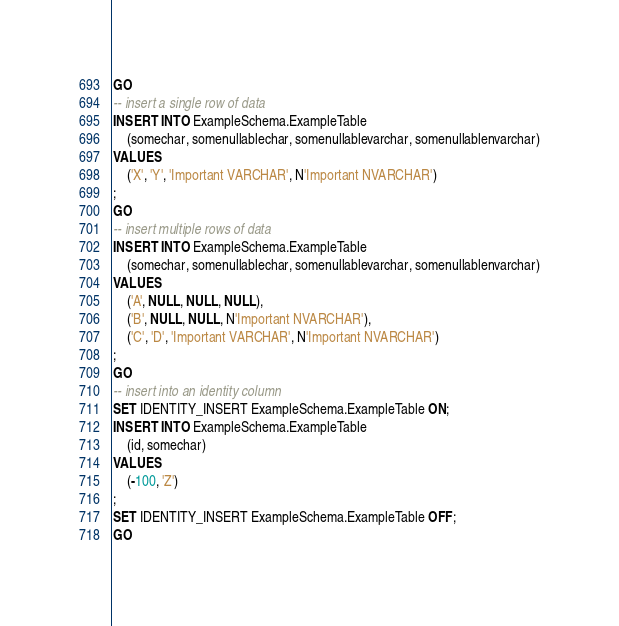Convert code to text. <code><loc_0><loc_0><loc_500><loc_500><_SQL_>GO
-- insert a single row of data
INSERT INTO ExampleSchema.ExampleTable
    (somechar, somenullablechar, somenullablevarchar, somenullablenvarchar)
VALUES
    ('X', 'Y', 'Important VARCHAR', N'Important NVARCHAR')
;
GO
-- insert multiple rows of data
INSERT INTO ExampleSchema.ExampleTable
    (somechar, somenullablechar, somenullablevarchar, somenullablenvarchar)
VALUES
    ('A', NULL, NULL, NULL),
    ('B', NULL, NULL, N'Important NVARCHAR'),
    ('C', 'D', 'Important VARCHAR', N'Important NVARCHAR')
;
GO
-- insert into an identity column
SET IDENTITY_INSERT ExampleSchema.ExampleTable ON;
INSERT INTO ExampleSchema.ExampleTable
    (id, somechar)
VALUES
    (-100, 'Z')
;
SET IDENTITY_INSERT ExampleSchema.ExampleTable OFF;
GO</code> 